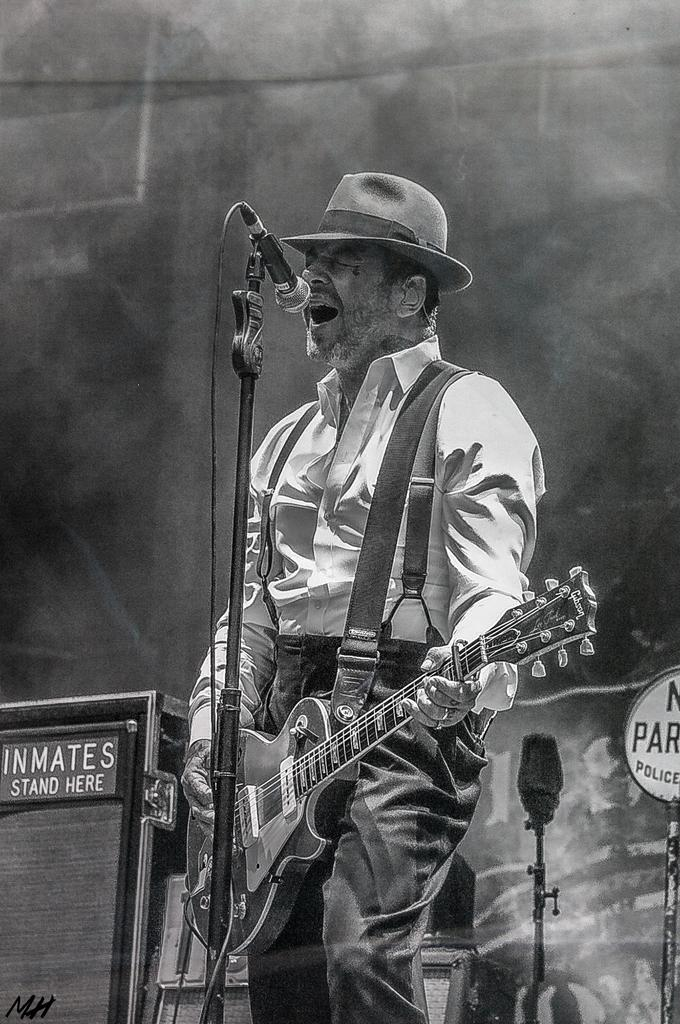Who is the main subject in the image? There is a man in the image. What is the man doing in the image? The man is standing in the image. What object is the man holding in the image? The man is holding a guitar in his hand. What is the color scheme of the image? The image is in black and white color. How many trees can be seen in the image? There are no trees visible in the image. What type of watch is the man wearing in the image? The image is in black and white, and there is no watch visible on the man's wrist. 